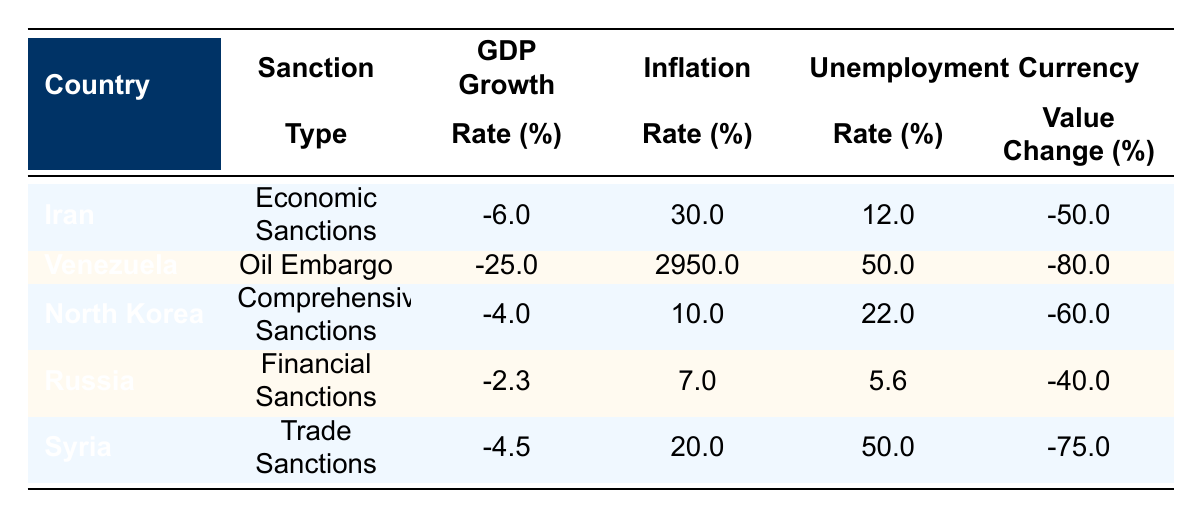What is the GDP growth rate for Venezuela? The table shows the GDP growth rate for Venezuela under the 'GDP Growth' column. The value listed for Venezuela is -25.0%.
Answer: -25.0% Which country experienced the highest inflation rate? By comparing the inflation rates in the table, we see that Venezuela has the highest inflation rate at 2950.0%.
Answer: Venezuela What is the average unemployment rate of the countries listed? To find the average, sum the unemployment rates: (12.0 + 50.0 + 22.0 + 5.6 + 50.0) = 139.6. There are 5 countries, so the average is 139.6 / 5 = 27.92%.
Answer: 27.92% Is the currency value change of Syria greater than that of Iran? The currency value change for Syria is -75.0% while for Iran, it is -50.0%. Since -75.0% is less than -50.0%, the statement is true.
Answer: Yes Which country had a lower GDP growth rate, Iran or North Korea? The GDP growth rate for Iran is -6.0% and for North Korea, it is -4.0%. Comparing these two, -6.0% (Iran) is lower than -4.0% (North Korea).
Answer: Iran What is the total currency value change for all five countries? Adding the currency value changes gives: (-50.0 + -80.0 + -60.0 + -40.0 + -75.0) = -305.0%.
Answer: -305.0% How many countries have an unemployment rate above 20%? By examining the unemployment rates: Iran (12.0%), Venezuela (50.0%), North Korea (22.0%), Russia (5.6%), and Syria (50.0%). The only countries above 20% are Venezuela, North Korea, and Syria, totaling three countries.
Answer: 3 Was there any country that had financial sanctions and experienced a GDP growth rate below -5%? Russia had financial sanctions and a GDP growth rate of -2.3%, which is above -5%. Therefore, no countries in the table meet the criteria of having financial sanctions and a GDP growth rate below -5%.
Answer: No What is the difference in inflation rates between the highest and lowest rates in the data? Venezuela has the highest inflation rate at 2950.0% and North Korea has the lowest at 10.0%. The difference is 2950.0% - 10.0% = 2940.0%.
Answer: 2940.0% 